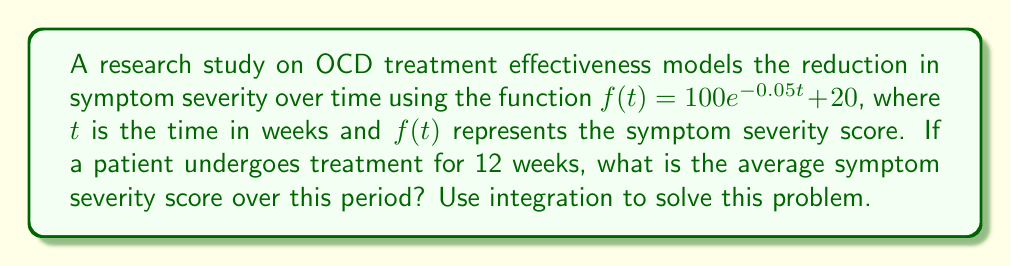Give your solution to this math problem. To find the average symptom severity score over the 12-week period, we need to:

1) Calculate the definite integral of $f(t)$ from $t=0$ to $t=12$
2) Divide the result by the time interval (12 weeks)

Step 1: Set up the integral
$$\frac{1}{12}\int_0^{12} (100e^{-0.05t} + 20) dt$$

Step 2: Integrate the function
$$\frac{1}{12}\left[-2000e^{-0.05t} + 20t\right]_0^{12}$$

Step 3: Evaluate the integral
$$\frac{1}{12}\left([-2000e^{-0.05(12)} + 20(12)] - [-2000e^{-0.05(0)} + 20(0)]\right)$$

Step 4: Simplify
$$\frac{1}{12}\left(-2000e^{-0.6} + 240 + 2000\right)$$
$$\frac{1}{12}\left(2240 - 2000e^{-0.6}\right)$$

Step 5: Calculate the final value
$$\frac{2240 - 2000e^{-0.6}}{12} \approx 71.65$$

Therefore, the average symptom severity score over the 12-week period is approximately 71.65.
Answer: 71.65 